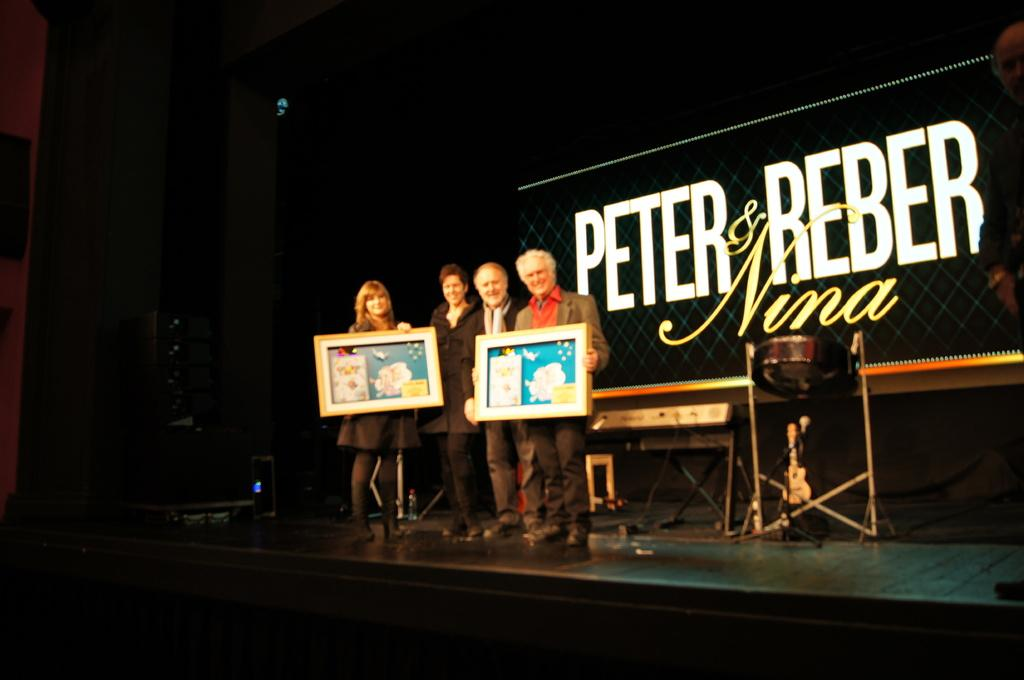How many people are present in the image? There are four people in the image. What are two of the people doing in the image? Two of the people are holding frames. What piece of furniture can be seen in the image? There is a desk in the image. Is there any text or writing visible in the image? Yes, there is something written in the image, possibly on the desk or a nearby surface. What type of pump is visible in the image, and what is it connected to in the image? There is no pump present in the image. 